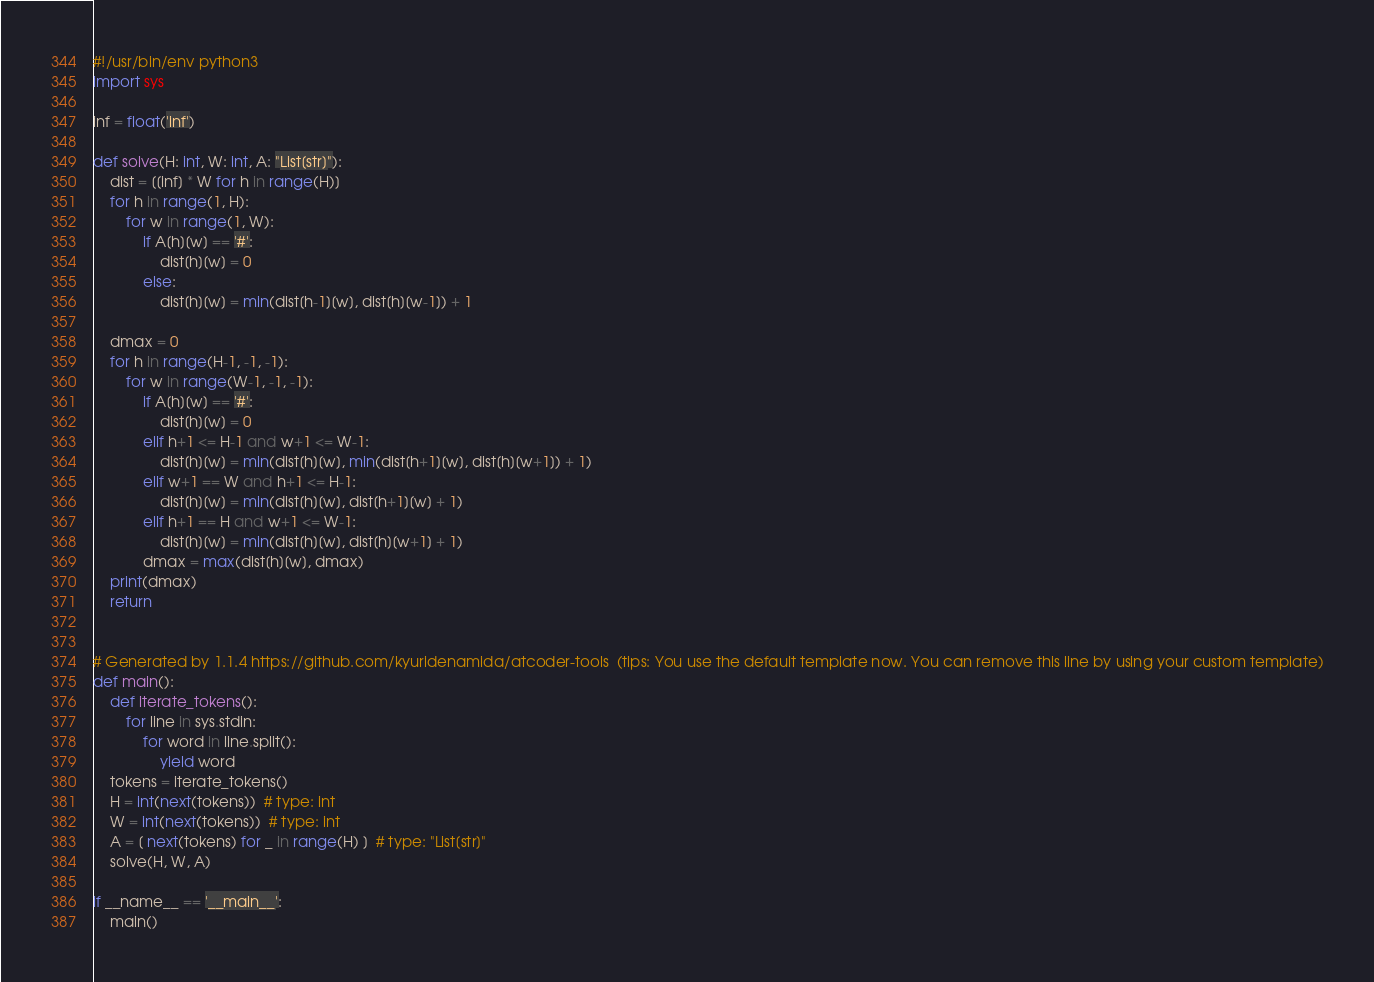<code> <loc_0><loc_0><loc_500><loc_500><_Python_>#!/usr/bin/env python3
import sys

inf = float('inf')

def solve(H: int, W: int, A: "List[str]"):
    dist = [[inf] * W for h in range(H)]
    for h in range(1, H):
        for w in range(1, W):
            if A[h][w] == '#':
                dist[h][w] = 0
            else:
                dist[h][w] = min(dist[h-1][w], dist[h][w-1]) + 1
    
    dmax = 0
    for h in range(H-1, -1, -1):
        for w in range(W-1, -1, -1):
            if A[h][w] == '#':
                dist[h][w] = 0
            elif h+1 <= H-1 and w+1 <= W-1:
                dist[h][w] = min(dist[h][w], min(dist[h+1][w], dist[h][w+1]) + 1)
            elif w+1 == W and h+1 <= H-1:
                dist[h][w] = min(dist[h][w], dist[h+1][w] + 1)
            elif h+1 == H and w+1 <= W-1:
                dist[h][w] = min(dist[h][w], dist[h][w+1] + 1)
            dmax = max(dist[h][w], dmax)
    print(dmax) 
    return


# Generated by 1.1.4 https://github.com/kyuridenamida/atcoder-tools  (tips: You use the default template now. You can remove this line by using your custom template)
def main():
    def iterate_tokens():
        for line in sys.stdin:
            for word in line.split():
                yield word
    tokens = iterate_tokens()
    H = int(next(tokens))  # type: int
    W = int(next(tokens))  # type: int
    A = [ next(tokens) for _ in range(H) ]  # type: "List[str]"
    solve(H, W, A)

if __name__ == '__main__':
    main()
</code> 